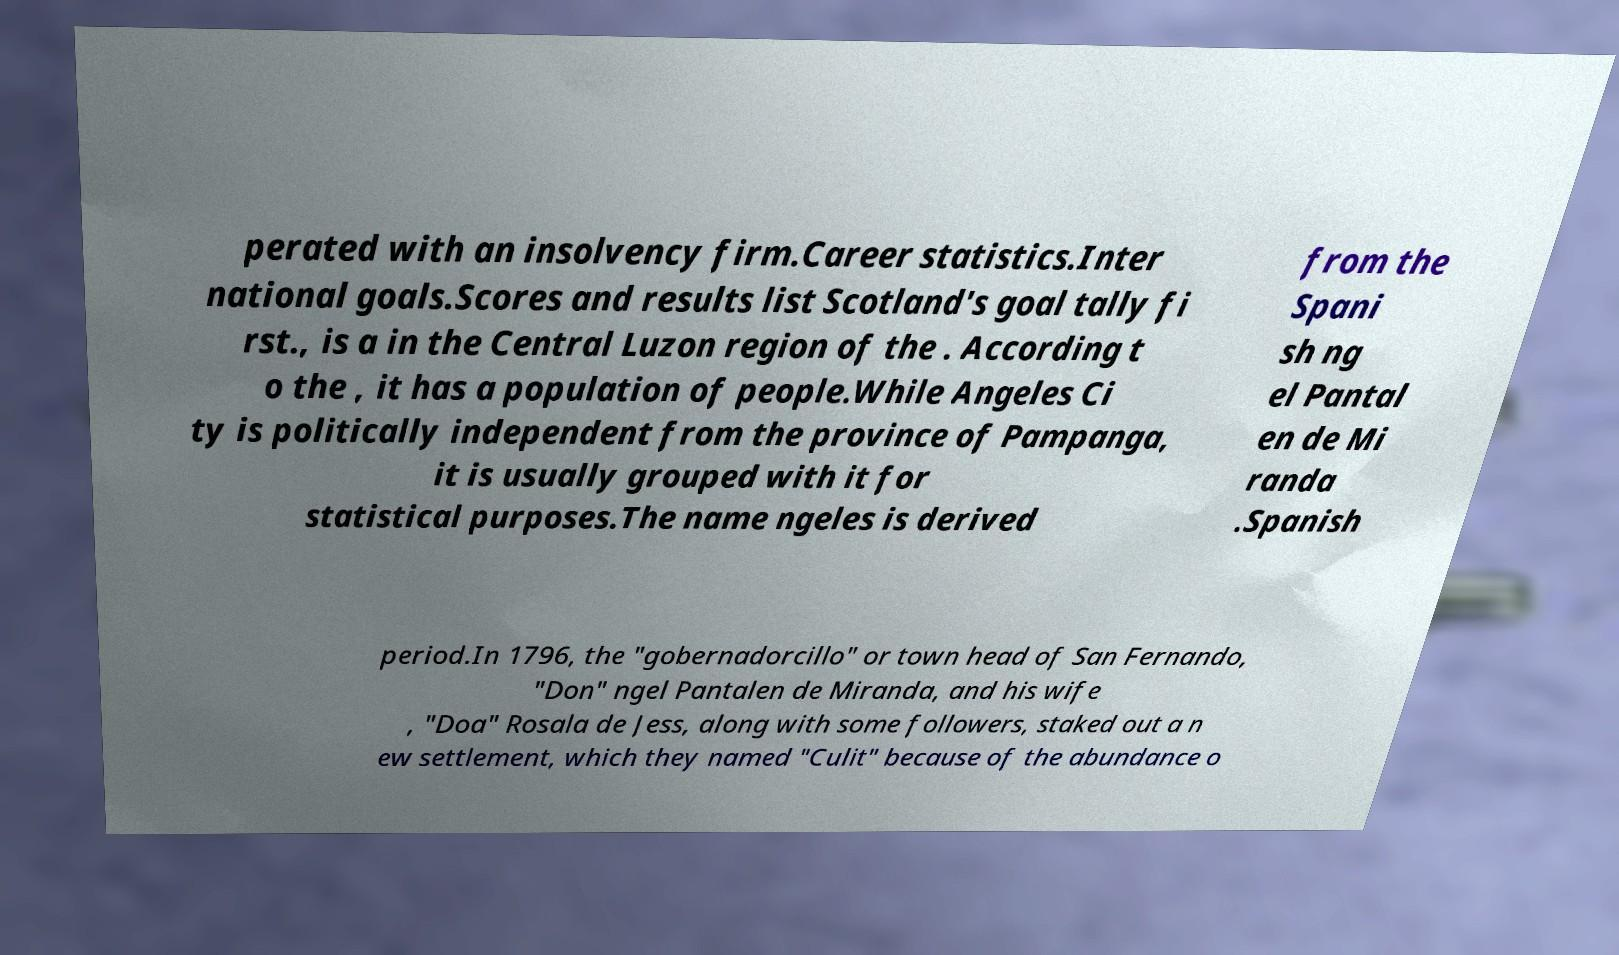What messages or text are displayed in this image? I need them in a readable, typed format. perated with an insolvency firm.Career statistics.Inter national goals.Scores and results list Scotland's goal tally fi rst., is a in the Central Luzon region of the . According t o the , it has a population of people.While Angeles Ci ty is politically independent from the province of Pampanga, it is usually grouped with it for statistical purposes.The name ngeles is derived from the Spani sh ng el Pantal en de Mi randa .Spanish period.In 1796, the "gobernadorcillo" or town head of San Fernando, "Don" ngel Pantalen de Miranda, and his wife , "Doa" Rosala de Jess, along with some followers, staked out a n ew settlement, which they named "Culit" because of the abundance o 